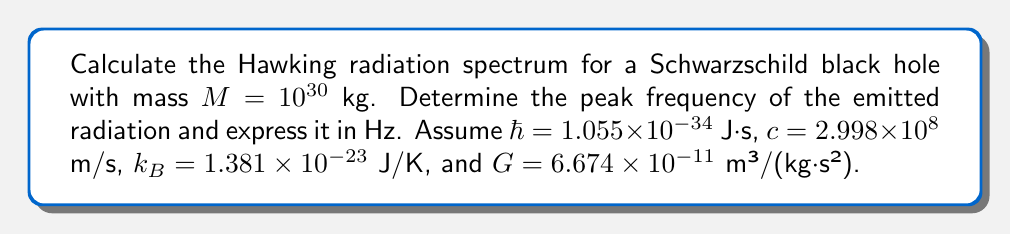Solve this math problem. 1) First, calculate the Hawking temperature $T_H$ for the black hole:
   $$T_H = \frac{\hbar c^3}{8\pi G M k_B}$$

2) Substitute the given values:
   $$T_H = \frac{(1.055 \times 10^{-34})(2.998 \times 10^8)^3}{8\pi (6.674 \times 10^{-11})(10^{30})(1.381 \times 10^{-23})}$$

3) Compute the result:
   $$T_H \approx 6.17 \times 10^{-8} \text{ K}$$

4) The spectrum of Hawking radiation follows a black body distribution. The peak frequency $\nu_{peak}$ is given by Wien's displacement law:
   $$\nu_{peak} = 2.82 \frac{k_B T_H}{h}$$

5) Substitute the values:
   $$\nu_{peak} = 2.82 \frac{(1.381 \times 10^{-23})(6.17 \times 10^{-8})}{6.626 \times 10^{-34}}$$

6) Compute the final result:
   $$\nu_{peak} \approx 3.62 \times 10^3 \text{ Hz}$$
Answer: $3.62 \times 10^3 \text{ Hz}$ 